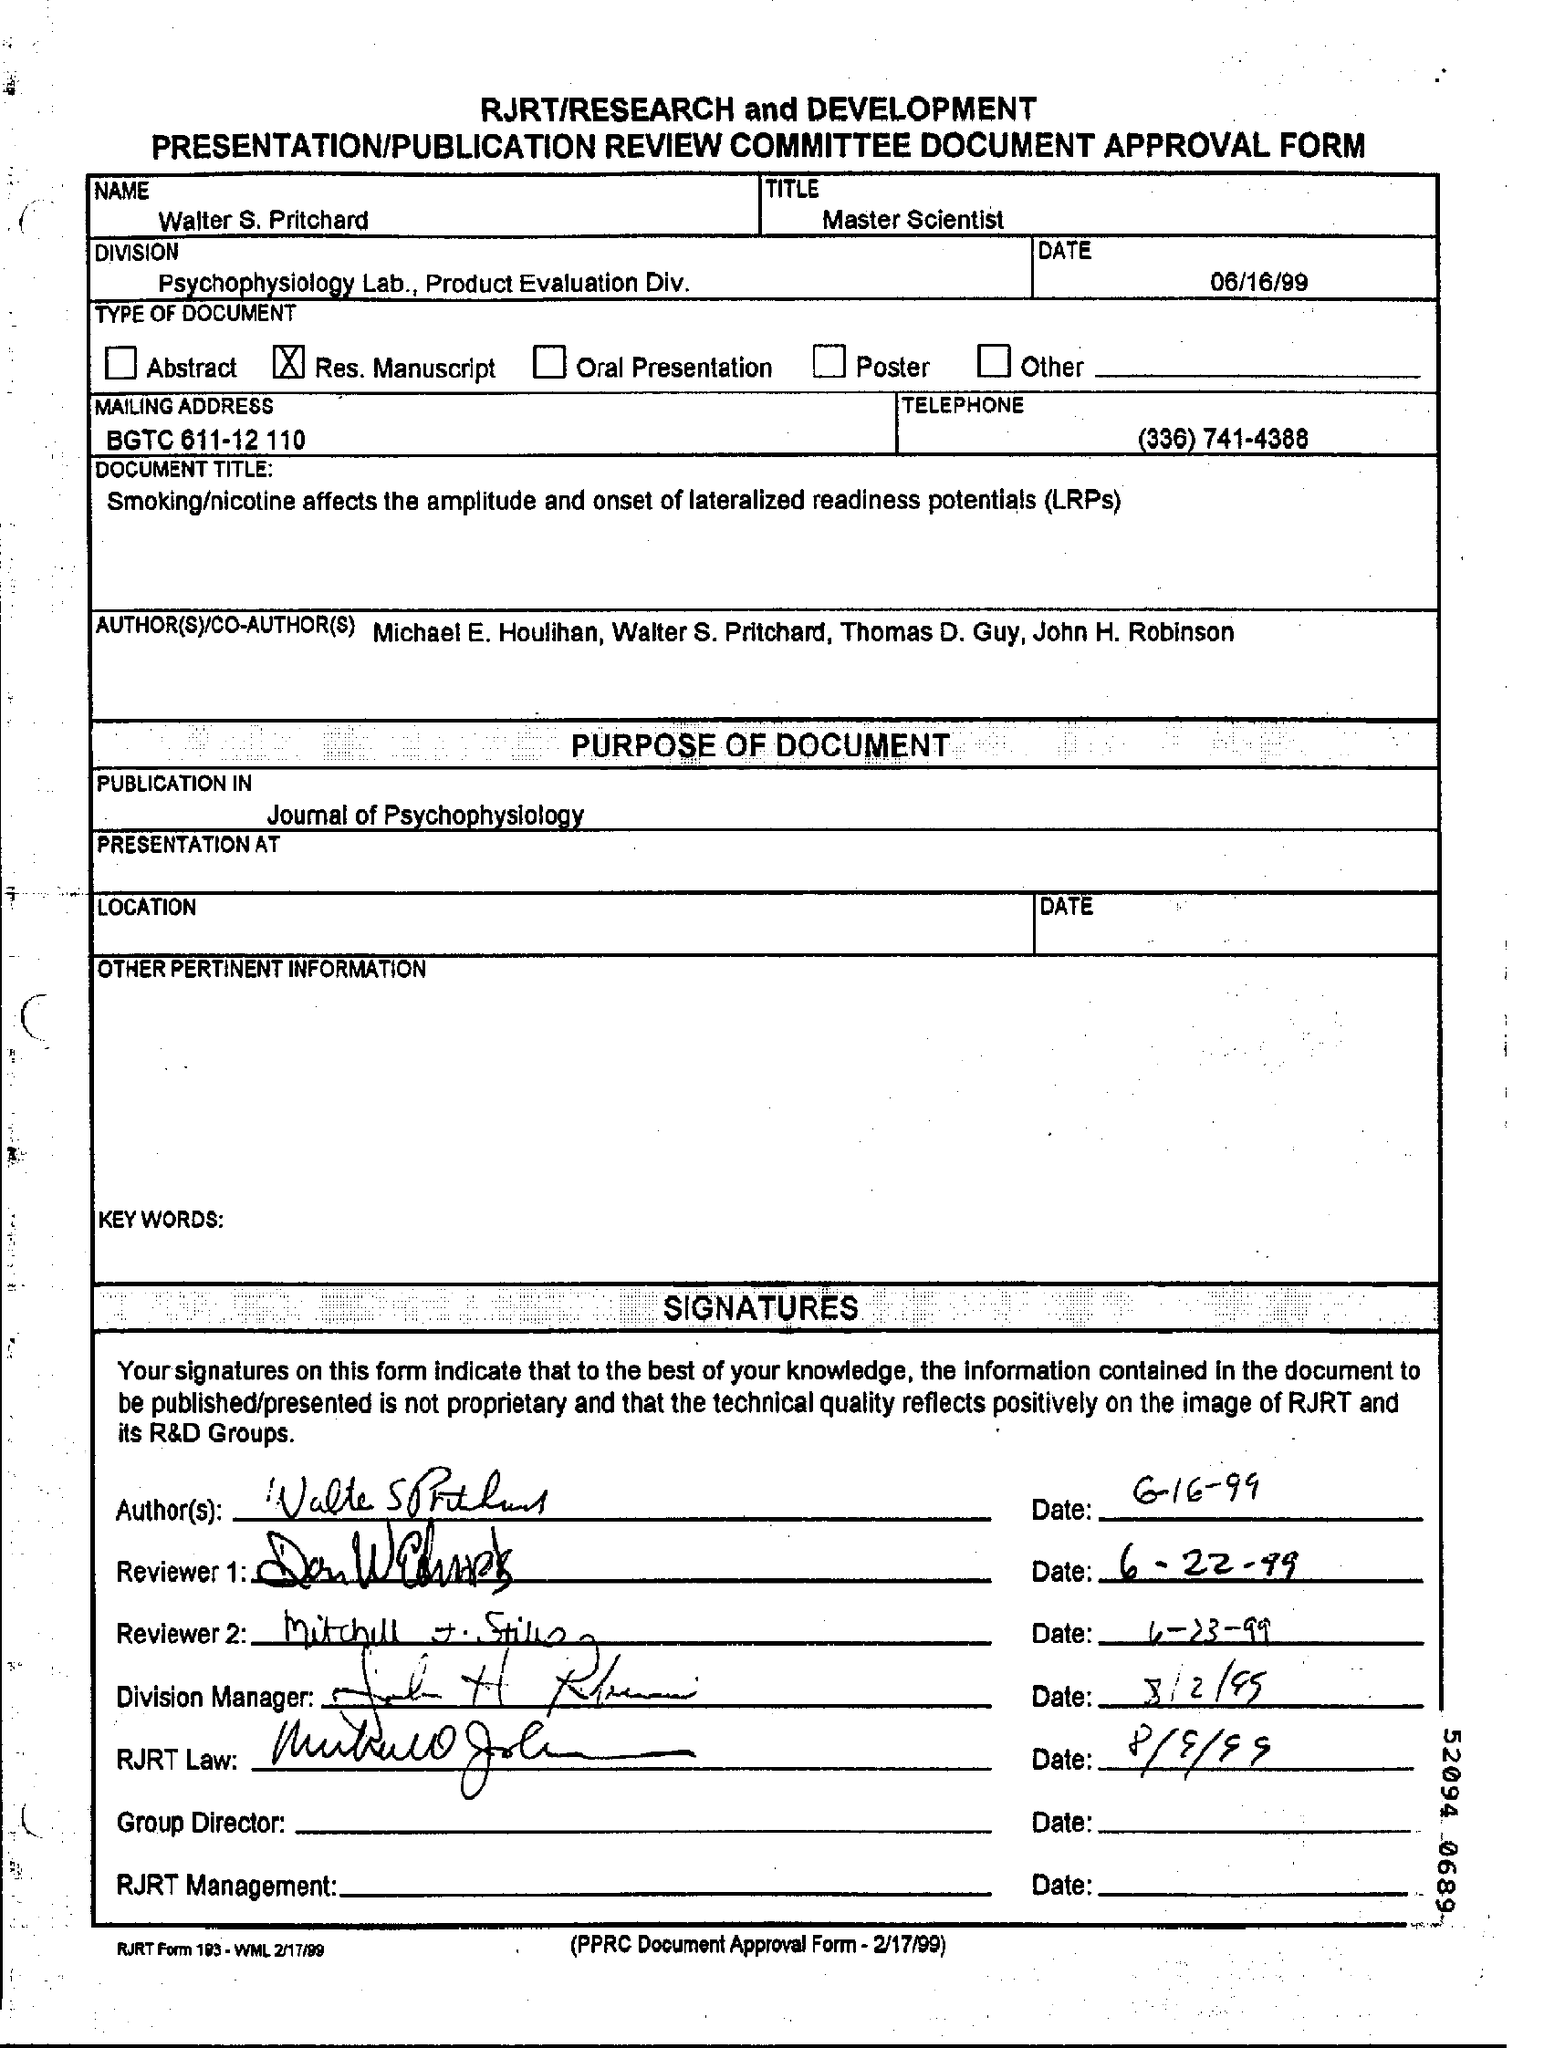What is the Date mentioned in the form ?
Ensure brevity in your answer.  06/16/99. What is the name written in the form ?
Your answer should be very brief. Walter S. Pritchard. What is written in the Title Field ?
Offer a very short reply. Master Scientist. What is the Telephone Number ?
Provide a succinct answer. (336) 741-4388. What is written in the Division field ?
Keep it short and to the point. Psychophysiology Lab, Product Evaluation Div. When Reviewer 1 signed on the document ?
Make the answer very short. 6-22-99. 